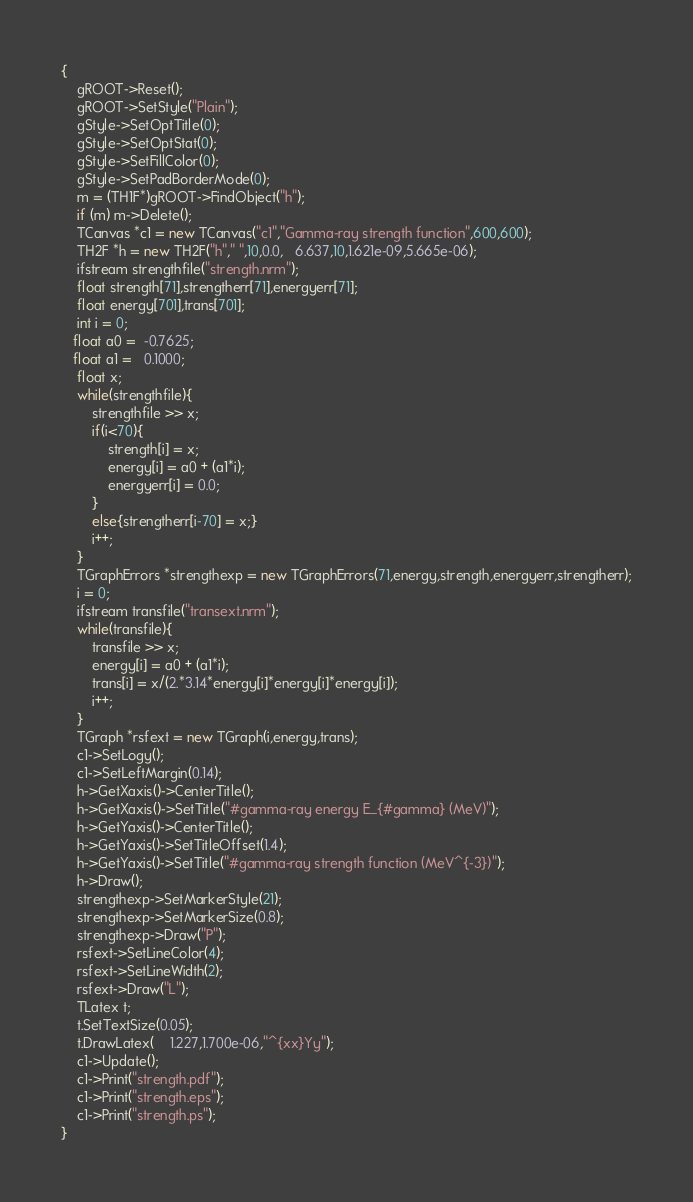Convert code to text. <code><loc_0><loc_0><loc_500><loc_500><_C++_>{
	gROOT->Reset();
	gROOT->SetStyle("Plain");
	gStyle->SetOptTitle(0);
	gStyle->SetOptStat(0);
	gStyle->SetFillColor(0);
	gStyle->SetPadBorderMode(0);
	m = (TH1F*)gROOT->FindObject("h");
	if (m) m->Delete();
	TCanvas *c1 = new TCanvas("c1","Gamma-ray strength function",600,600);
	TH2F *h = new TH2F("h"," ",10,0.0,   6.637,10,1.621e-09,5.665e-06);
	ifstream strengthfile("strength.nrm");
	float strength[71],strengtherr[71],energyerr[71];
	float energy[701],trans[701];
	int i = 0;
   float a0 =  -0.7625;
   float a1 =   0.1000;
	float x;	
	while(strengthfile){
		strengthfile >> x;
		if(i<70){
			strength[i] = x;
			energy[i] = a0 + (a1*i);
			energyerr[i] = 0.0;
		}	
		else{strengtherr[i-70] = x;}
		i++;
	}
	TGraphErrors *strengthexp = new TGraphErrors(71,energy,strength,energyerr,strengtherr);
    i = 0;
    ifstream transfile("transext.nrm");
    while(transfile){
        transfile >> x;
        energy[i] = a0 + (a1*i);
        trans[i] = x/(2.*3.14*energy[i]*energy[i]*energy[i]);
        i++;
    }
    TGraph *rsfext = new TGraph(i,energy,trans);
	c1->SetLogy();
	c1->SetLeftMargin(0.14);
	h->GetXaxis()->CenterTitle();
	h->GetXaxis()->SetTitle("#gamma-ray energy E_{#gamma} (MeV)");
	h->GetYaxis()->CenterTitle();
	h->GetYaxis()->SetTitleOffset(1.4);
	h->GetYaxis()->SetTitle("#gamma-ray strength function (MeV^{-3})");
	h->Draw();
	strengthexp->SetMarkerStyle(21);
	strengthexp->SetMarkerSize(0.8);
	strengthexp->Draw("P");
    rsfext->SetLineColor(4);
    rsfext->SetLineWidth(2);
    rsfext->Draw("L");
	TLatex t;
	t.SetTextSize(0.05);
	t.DrawLatex(    1.227,1.700e-06,"^{xx}Yy");
	c1->Update();
	c1->Print("strength.pdf");
	c1->Print("strength.eps");
	c1->Print("strength.ps");
}
</code> 